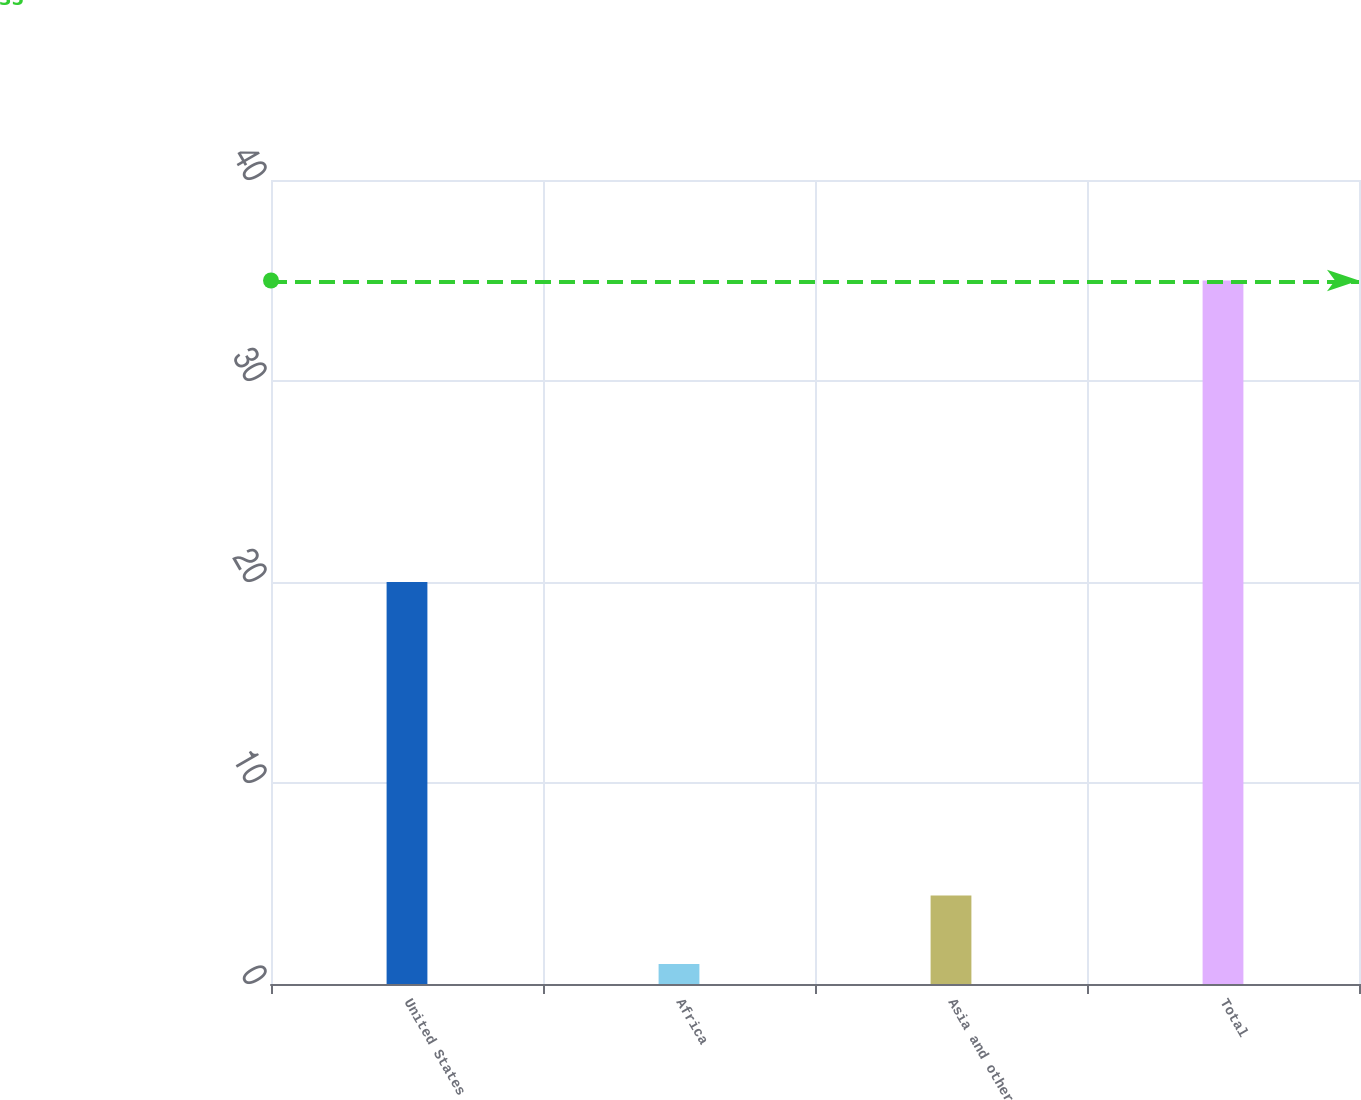<chart> <loc_0><loc_0><loc_500><loc_500><bar_chart><fcel>United States<fcel>Africa<fcel>Asia and other<fcel>Total<nl><fcel>20<fcel>1<fcel>4.4<fcel>35<nl></chart> 